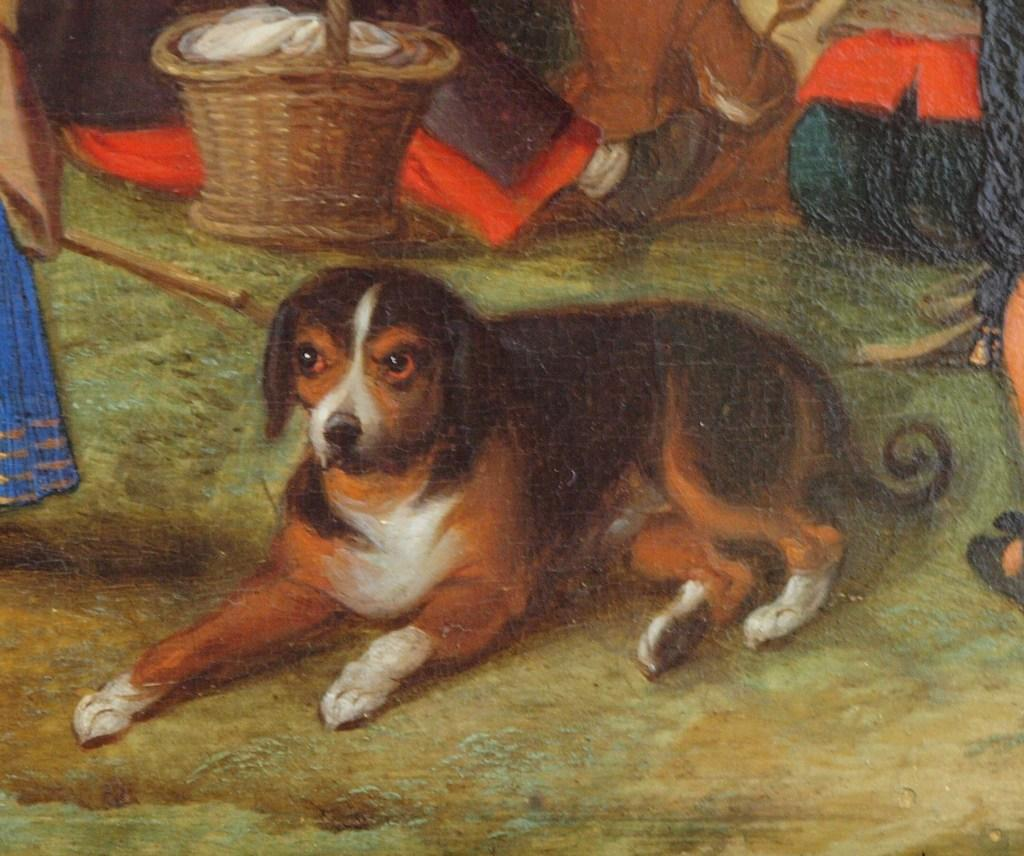What is the main subject of the painting in the image? The painting depicts a dog. Are there any other living beings in the painting? Yes, the painting features people. What objects are included in the painting besides the dog and people? The painting includes a basket and other objects. What type of rhythm can be heard coming from the cemetery in the painting? There is no cemetery present in the painting, and therefore no rhythm can be heard. 